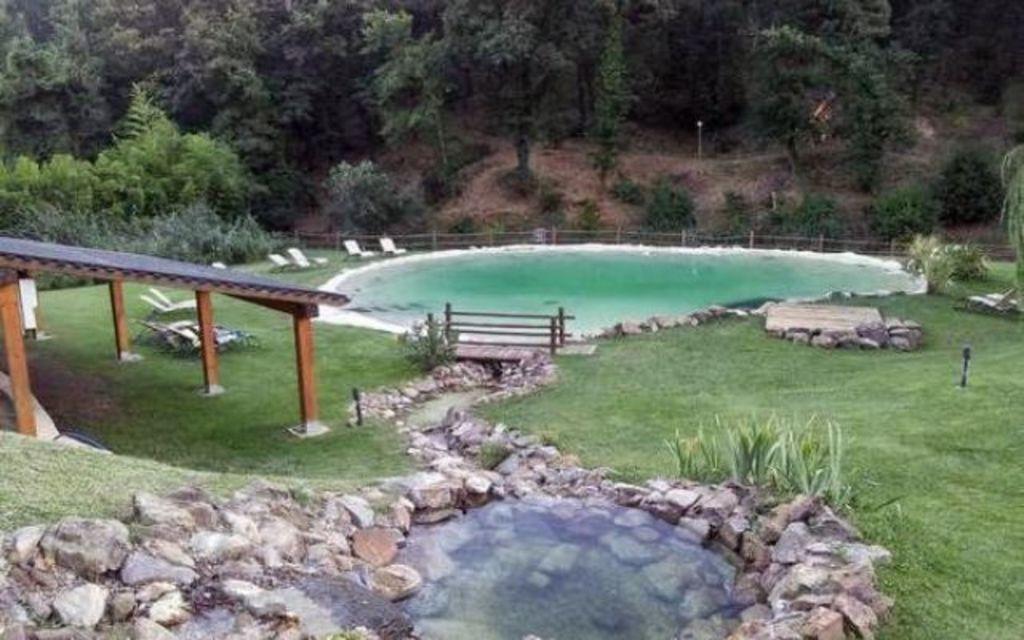Describe this image in one or two sentences. In this image I can see swimming pool in the middle, beside that there are some benches, pond, shed and trees. 